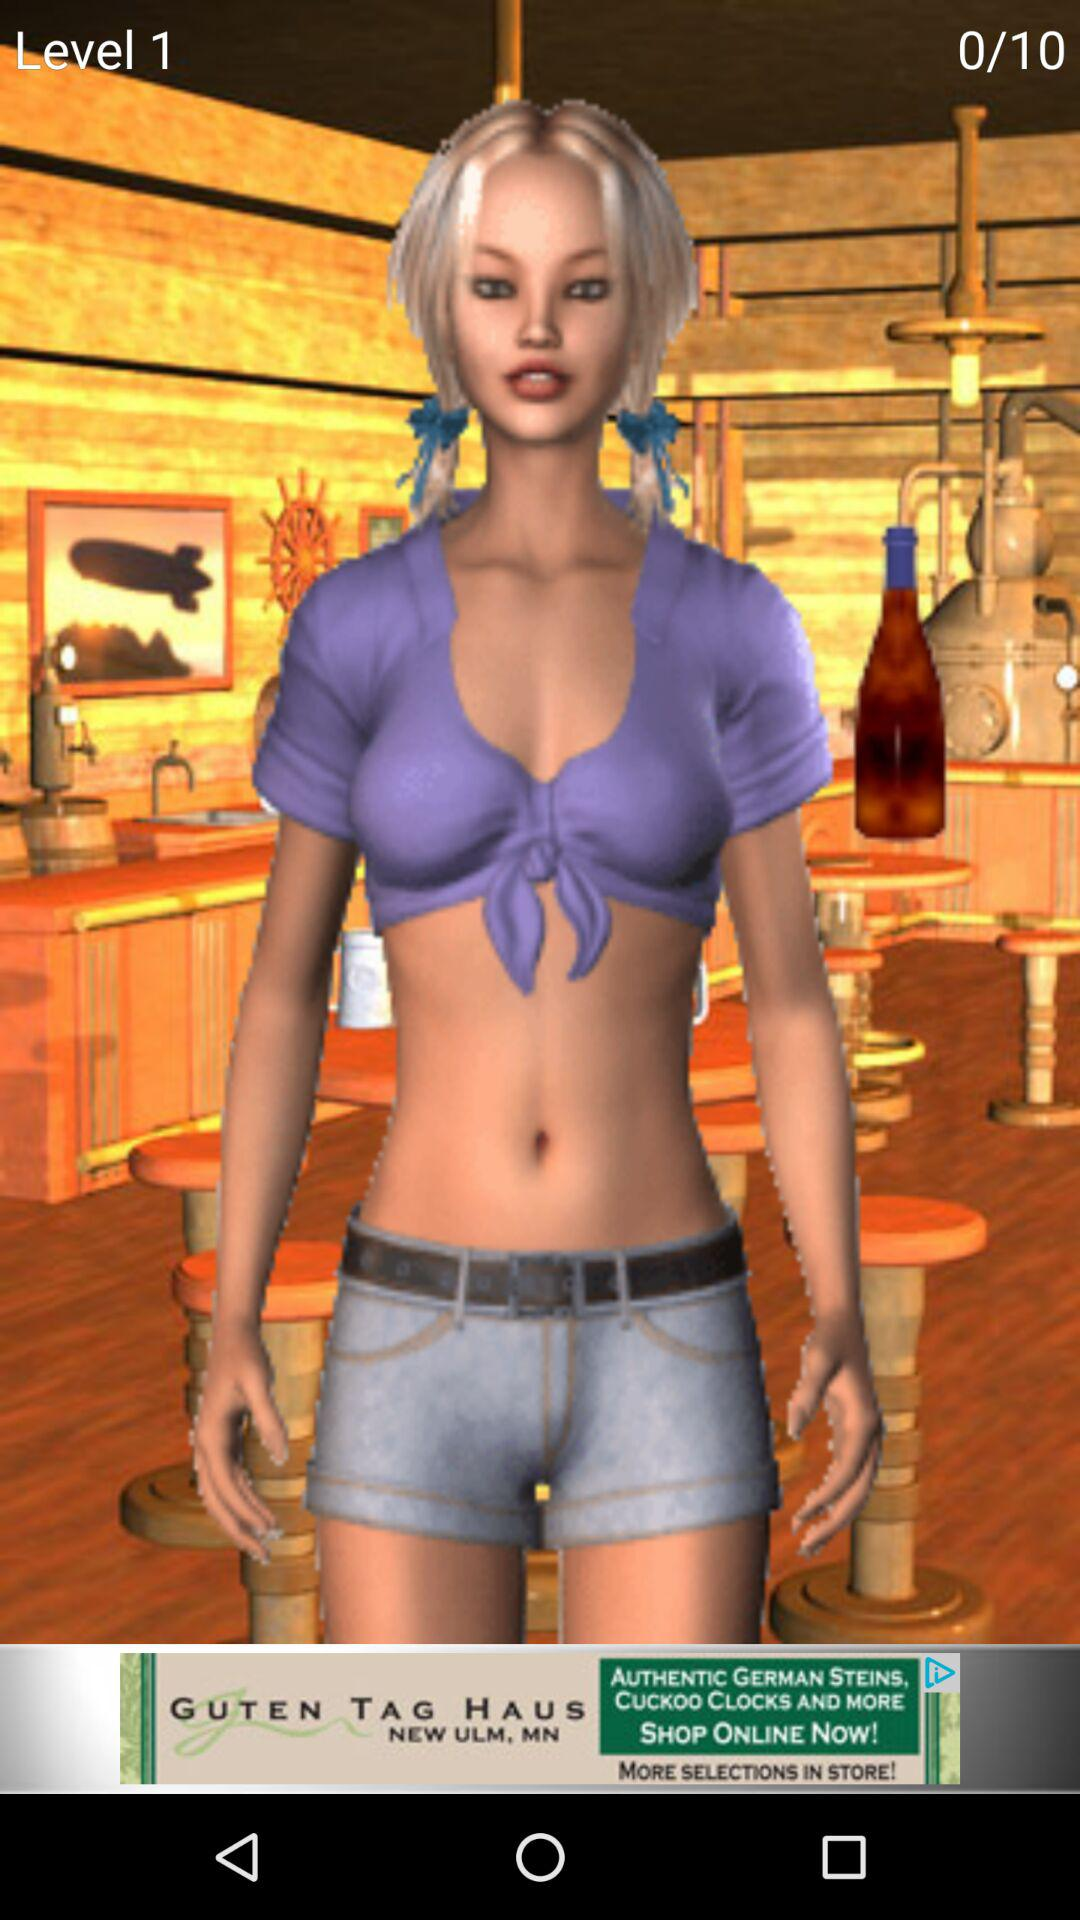How many more levels are there than the current level?
Answer the question using a single word or phrase. 9 